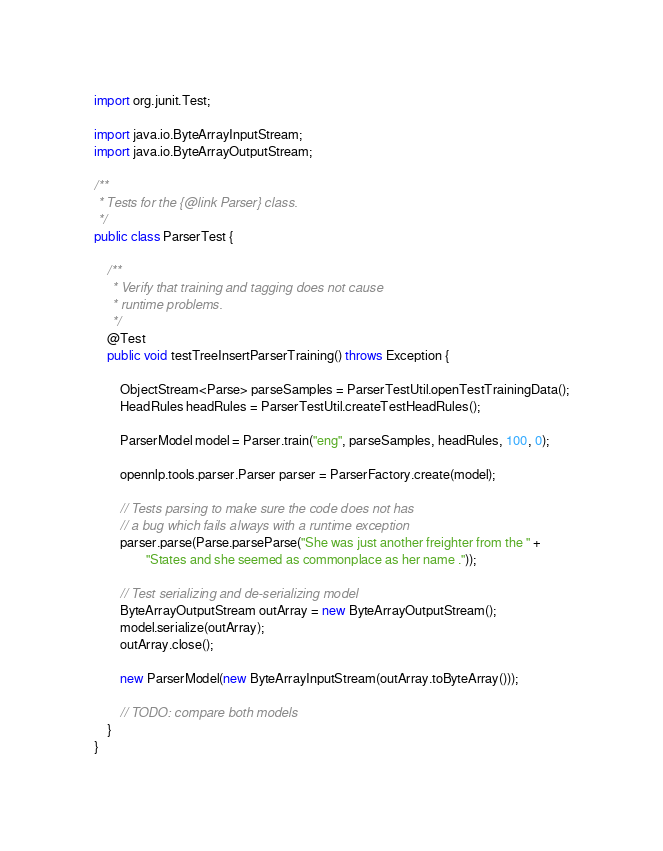Convert code to text. <code><loc_0><loc_0><loc_500><loc_500><_Java_>import org.junit.Test;

import java.io.ByteArrayInputStream;
import java.io.ByteArrayOutputStream;

/**
 * Tests for the {@link Parser} class.
 */
public class ParserTest {

    /**
     * Verify that training and tagging does not cause
     * runtime problems.
     */
    @Test
    public void testTreeInsertParserTraining() throws Exception {

        ObjectStream<Parse> parseSamples = ParserTestUtil.openTestTrainingData();
        HeadRules headRules = ParserTestUtil.createTestHeadRules();

        ParserModel model = Parser.train("eng", parseSamples, headRules, 100, 0);

        opennlp.tools.parser.Parser parser = ParserFactory.create(model);

        // Tests parsing to make sure the code does not has
        // a bug which fails always with a runtime exception
        parser.parse(Parse.parseParse("She was just another freighter from the " +
                "States and she seemed as commonplace as her name ."));

        // Test serializing and de-serializing model
        ByteArrayOutputStream outArray = new ByteArrayOutputStream();
        model.serialize(outArray);
        outArray.close();

        new ParserModel(new ByteArrayInputStream(outArray.toByteArray()));

        // TODO: compare both models
    }
}
</code> 